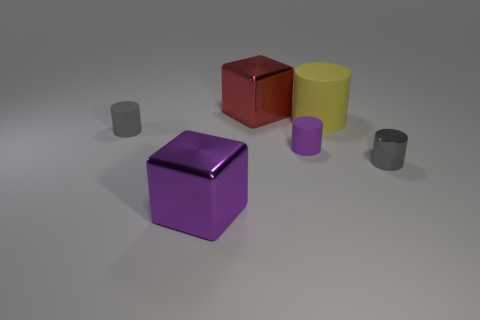Are there any other things of the same color as the big rubber cylinder?
Give a very brief answer. No. There is a small gray object that is left of the small metal cylinder; does it have the same shape as the large object in front of the big yellow matte thing?
Provide a succinct answer. No. What color is the large object in front of the thing to the left of the large metal cube in front of the small gray shiny cylinder?
Give a very brief answer. Purple. What is the color of the metallic cube that is in front of the gray shiny object?
Your answer should be very brief. Purple. There is a matte cylinder that is the same size as the purple shiny thing; what color is it?
Your answer should be compact. Yellow. Is the size of the yellow rubber cylinder the same as the purple cylinder?
Your answer should be very brief. No. There is a big yellow rubber cylinder; how many yellow rubber objects are right of it?
Your response must be concise. 0. What number of objects are tiny gray things to the left of the tiny shiny cylinder or big red metallic cubes?
Give a very brief answer. 2. Are there more metallic blocks in front of the big rubber cylinder than big rubber objects in front of the purple shiny block?
Provide a short and direct response. Yes. Does the yellow cylinder have the same size as the rubber cylinder that is to the left of the purple matte cylinder?
Your answer should be compact. No. 